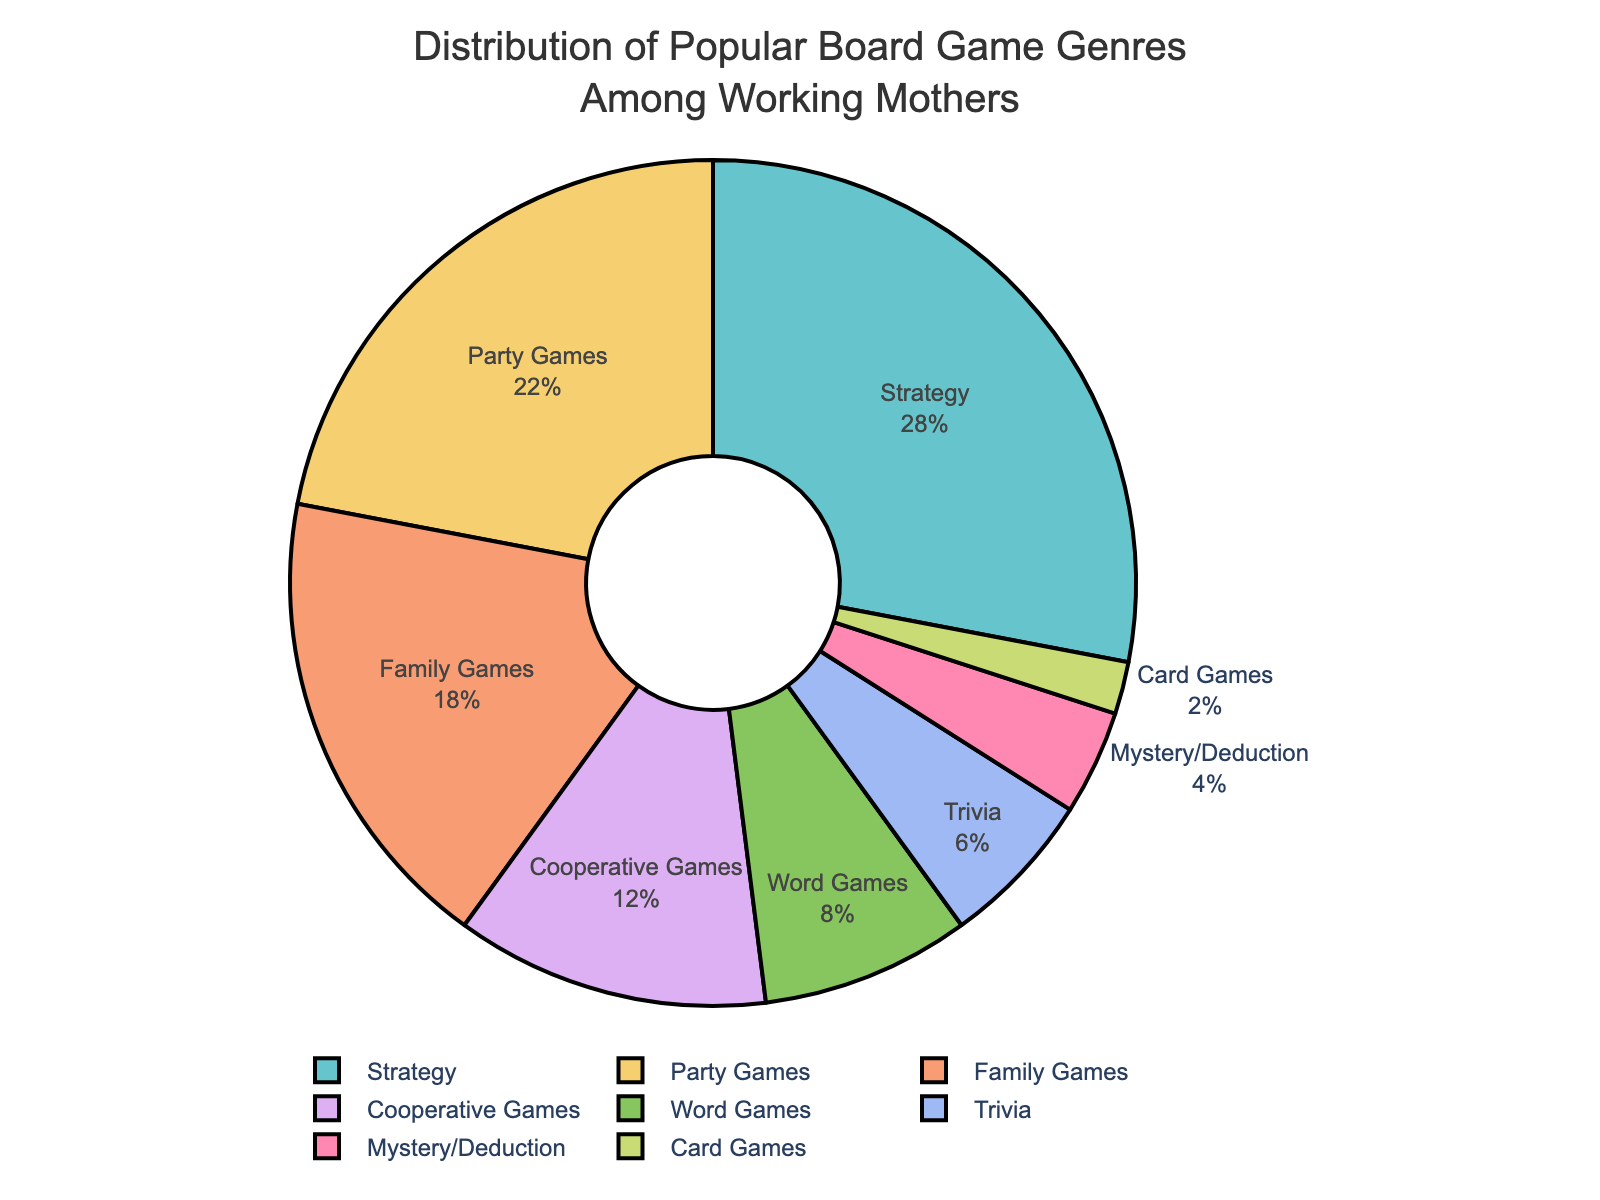What's the most popular board game genre among working mothers? The pie chart shows that Strategy games make up the largest percentage of the distribution. Therefore, Strategy games are the most popular genre among working mothers.
Answer: Strategy What is the combined percentage of Party Games and Family Games? From the pie chart, Party Games have 22% and Family Games have 18%. Adding these together gives 22% + 18% = 40%.
Answer: 40% Are Cooperative Games more popular than Word Games? The pie chart indicates that Cooperative Games have a 12% share, while Word Games have an 8% share. Since 12% is greater than 8%, Cooperative Games are more popular than Word Games.
Answer: Yes Which genres together make up more than half of the distribution? Strategy (28%), Party Games (22%), and Family Games (18%) are the top three genres. By summing their percentages: 28% + 22% + 18% = 68%, which is more than half. So, these three genres together make up more than half of the distribution.
Answer: Strategy, Party Games, Family Games How much more popular is the most popular genre compared to the least popular genre? The most popular genre is Strategy at 28%, and the least popular genre is Card Games at 2%. The difference is 28% - 2% = 26%.
Answer: 26% What percentage of the distribution is not accounted for by Strategy, Party Games, and Family Games? The combined percentage for Strategy (28%), Party Games (22%), and Family Games (18%) is 28% + 22% + 18% = 68%. Subtracting this from 100% gives 100% - 68% = 32%.
Answer: 32% What proportion of the total genres have a share of 10% or more? The genres with 10% or more are Strategy (28%), Party Games (22%), and Family Games (18%), and Cooperative Games (12%). Out of 8 genres, 4 have shares of 10% or more. So, 4 out of 8 is 4/8 or 50%.
Answer: 50% Which genre represents half the percentage of Strategy games? Strategy games have 28%. Half of 28% is 28% / 2 = 14%. Among the genres, none of them are exactly 14%. The closest one is Cooperative Games with 12%
Answer: Cooperative Games (closest) Is the total percentage of Mystery/Deduction, Trivia, and Card Games greater than Cooperative Games? Mystery/Deduction (4%) + Trivia (6%) + Card Games (2%) = 4% + 6% + 2% = 12%, which is equal to the percentage for Cooperative Games (12%).
Answer: No 